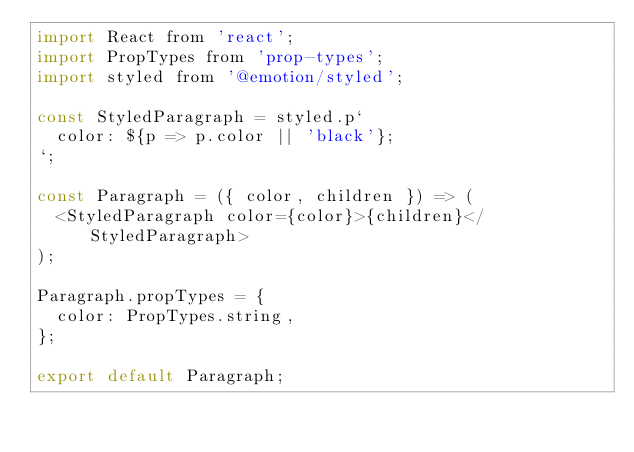Convert code to text. <code><loc_0><loc_0><loc_500><loc_500><_JavaScript_>import React from 'react';
import PropTypes from 'prop-types';
import styled from '@emotion/styled';

const StyledParagraph = styled.p`
  color: ${p => p.color || 'black'};
`;

const Paragraph = ({ color, children }) => (
  <StyledParagraph color={color}>{children}</StyledParagraph>
);

Paragraph.propTypes = {
  color: PropTypes.string,
};

export default Paragraph;
</code> 